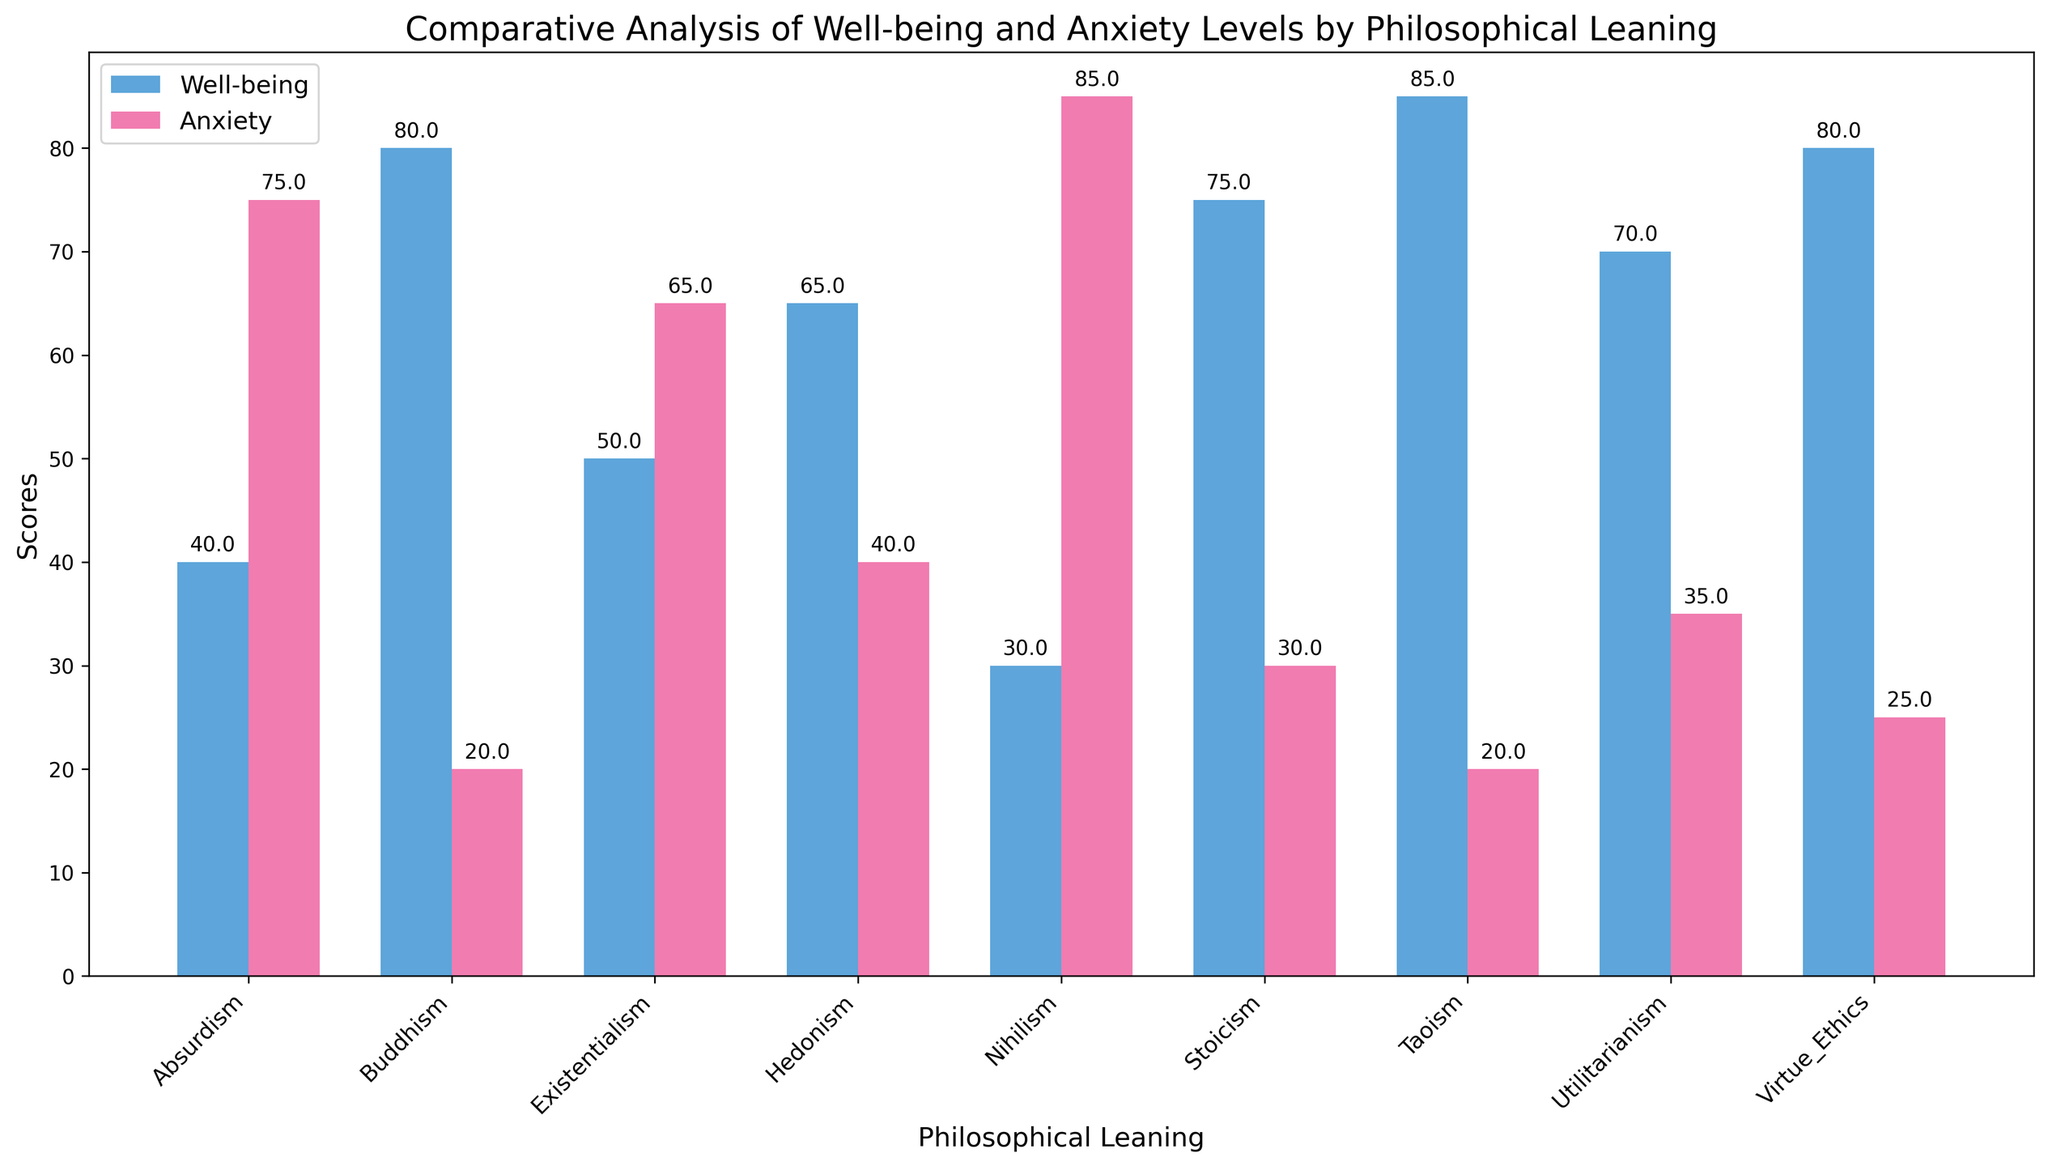Which philosophical leaning has the highest Well-being Score? By visually examining the heights of the blue bars, which represent Well-being Scores, we can see that Taoism has the tallest bar reflecting the highest score.
Answer: Taoism Which philosophical leaning has the highest Anxiety Score? By visually examining the heights of the red bars, which represent Anxiety Scores, we can see that Nihilism has the tallest bar reflecting the highest score.
Answer: Nihilism Compare the Well-being and Anxiety Scores of Buddhism. Which one is higher? For Buddhism, the blue bar (Well-being Score) is higher than the red bar (Anxiety Score).
Answer: Well-being Score What is the difference between the Well-being and Anxiety Scores of Stoicism? The Well-being Score of Stoicism is approximately 75 and the Anxiety Score is around 30. The difference is calculated as 75 - 30.
Answer: 45 What’s the sum of the Well-being Scores for Virtue Ethics and Taoism? Summing the Well-being Scores of Virtue Ethics (around 80) and Taoism (around 85), we get 80 + 85.
Answer: 165 Which philosophical leaning has the smallest difference between Well-being and Anxiety Scores? By examining the differences between the heights of blue and red bars for each philosophical leaning, we can see that Utilitarianism has the smallest difference between Well-being and Anxiety Scores.
Answer: Utilitarianism Which group has a higher average Well-being Score: Existentialism or Absurdism? By comparing the heights of the blue bars for Existentialism and Absurdism, it is clear that Existentialism has higher average Well-being Scores than Absurdism.
Answer: Existentialism What’s the average Anxiety Score for Hedonism based on the plot? Visually assessing the average height of the red bars for Hedonism, the Anxiety Score appears to be around 40.
Answer: 40 Which philosophical leaning has the lowest Well-being Score? The philosophical leaning with the shortest blue bar, indicating the lowest Well-being Score, is Nihilism.
Answer: Nihilism 